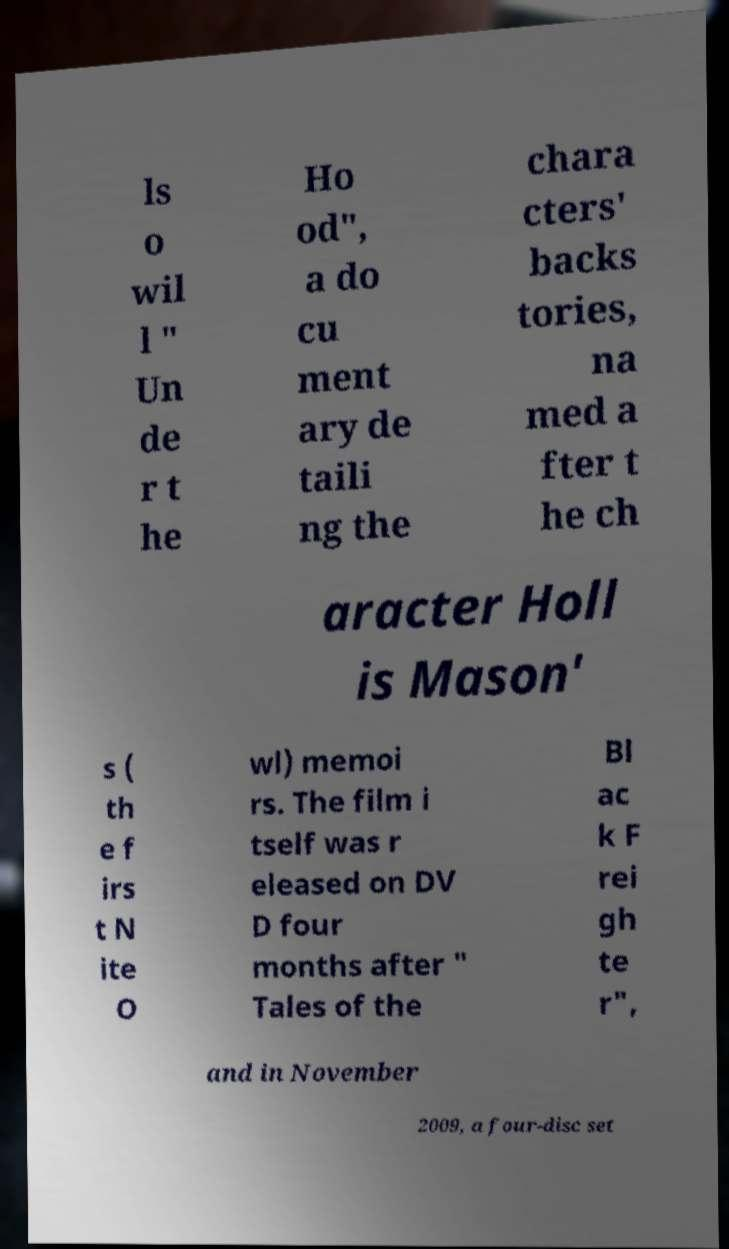I need the written content from this picture converted into text. Can you do that? ls o wil l " Un de r t he Ho od", a do cu ment ary de taili ng the chara cters' backs tories, na med a fter t he ch aracter Holl is Mason' s ( th e f irs t N ite O wl) memoi rs. The film i tself was r eleased on DV D four months after " Tales of the Bl ac k F rei gh te r", and in November 2009, a four-disc set 